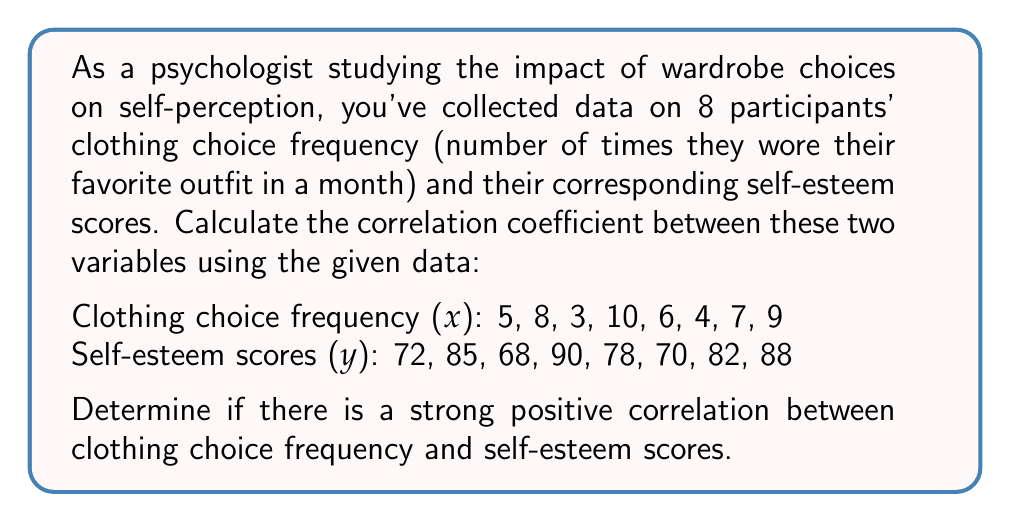Show me your answer to this math problem. To calculate the correlation coefficient (r) between clothing choice frequency (x) and self-esteem scores (y), we'll use the formula:

$$ r = \frac{n\sum xy - \sum x \sum y}{\sqrt{[n\sum x^2 - (\sum x)^2][n\sum y^2 - (\sum y)^2]}} $$

Where n is the number of data points.

Step 1: Calculate the required sums:
$n = 8$
$\sum x = 5 + 8 + 3 + 10 + 6 + 4 + 7 + 9 = 52$
$\sum y = 72 + 85 + 68 + 90 + 78 + 70 + 82 + 88 = 633$
$\sum xy = (5 \times 72) + (8 \times 85) + ... + (9 \times 88) = 4286$
$\sum x^2 = 5^2 + 8^2 + 3^2 + 10^2 + 6^2 + 4^2 + 7^2 + 9^2 = 368$
$\sum y^2 = 72^2 + 85^2 + 68^2 + 90^2 + 78^2 + 70^2 + 82^2 + 88^2 = 50,549$

Step 2: Substitute these values into the correlation coefficient formula:

$$ r = \frac{8(4286) - (52)(633)}{\sqrt{[8(368) - (52)^2][8(50,549) - (633)^2]}} $$

Step 3: Simplify and calculate:

$$ r = \frac{34,288 - 32,916}{\sqrt{(2,944 - 2,704)(404,392 - 400,689)}} $$

$$ r = \frac{1,372}{\sqrt{(240)(3,703)}} = \frac{1,372}{\sqrt{888,720}} = \frac{1,372}{942.72} $$

$$ r \approx 0.9455 $$

Step 4: Interpret the result:
The correlation coefficient ranges from -1 to 1, where:
- Values close to 1 indicate a strong positive correlation
- Values close to -1 indicate a strong negative correlation
- Values close to 0 indicate little to no correlation

With r ≈ 0.9455, we can conclude that there is a strong positive correlation between clothing choice frequency and self-esteem scores.
Answer: The correlation coefficient is approximately 0.9455, indicating a strong positive correlation between clothing choice frequency and self-esteem scores. 